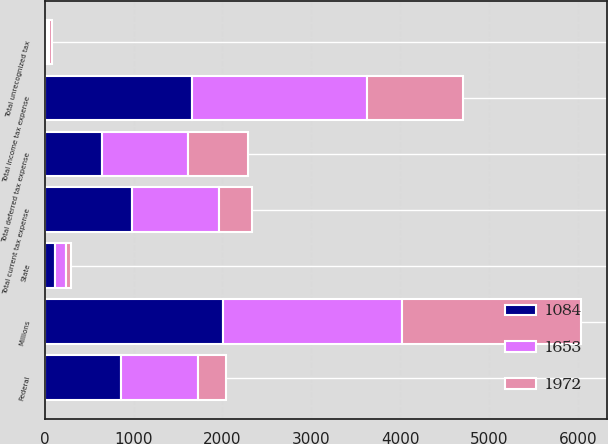Convert chart. <chart><loc_0><loc_0><loc_500><loc_500><stacked_bar_chart><ecel><fcel>Millions<fcel>Federal<fcel>State<fcel>Total current tax expense<fcel>Total deferred tax expense<fcel>Total unrecognized tax<fcel>Total income tax expense<nl><fcel>1653<fcel>2011<fcel>862<fcel>124<fcel>986<fcel>964<fcel>22<fcel>1972<nl><fcel>1084<fcel>2010<fcel>862<fcel>119<fcel>981<fcel>647<fcel>25<fcel>1653<nl><fcel>1972<fcel>2009<fcel>316<fcel>50<fcel>366<fcel>680<fcel>38<fcel>1084<nl></chart> 